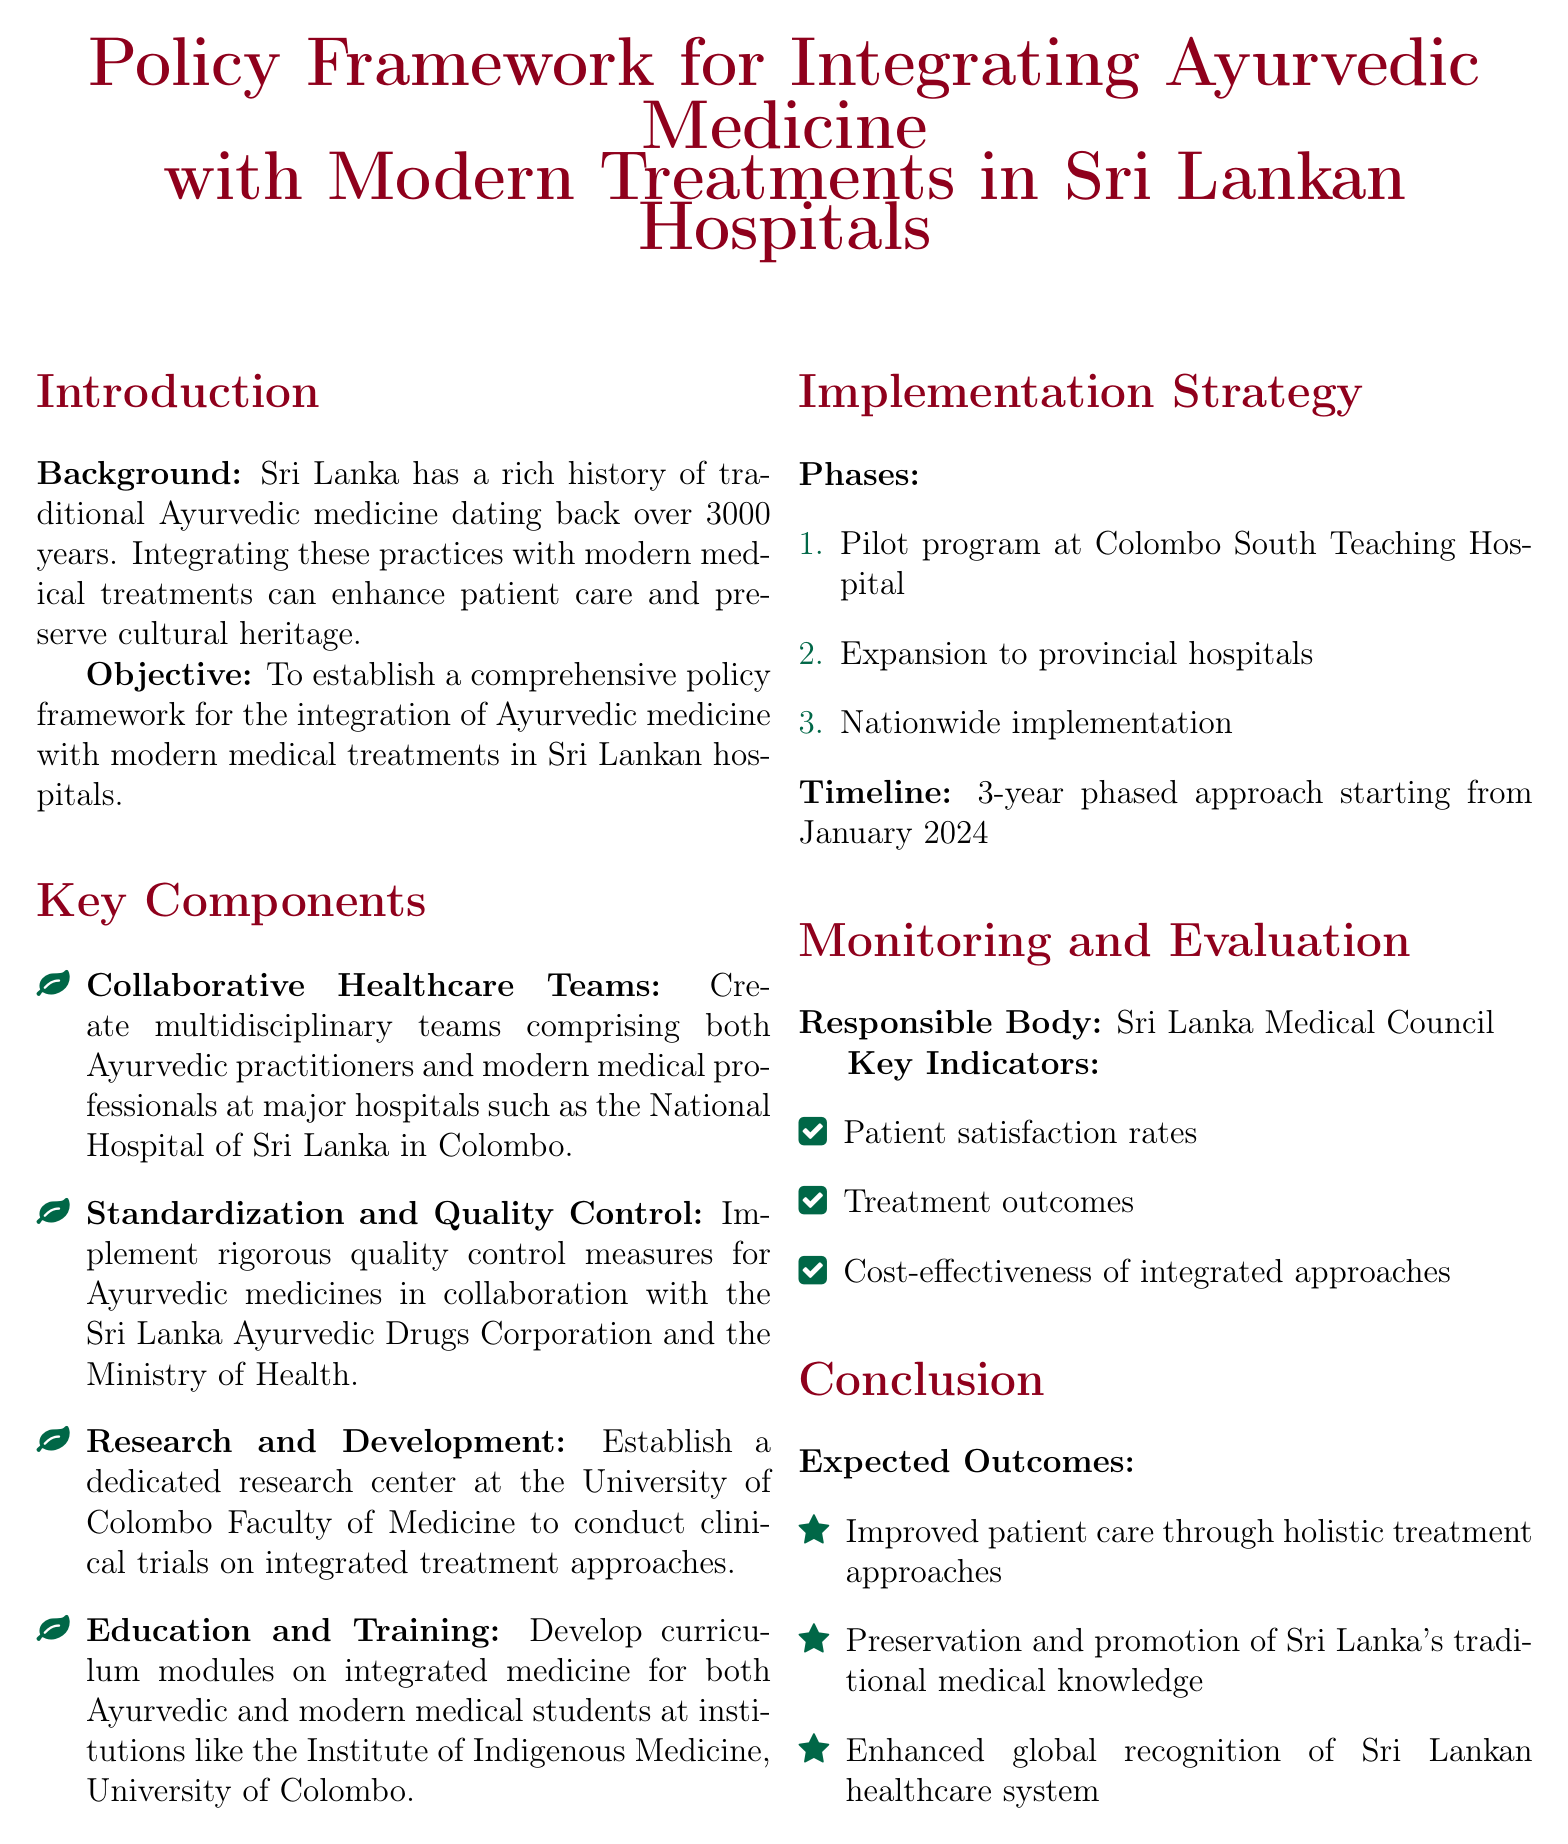What is the primary objective of the policy framework? The document states the objective is to establish a comprehensive policy framework for integration.
Answer: Establish a comprehensive policy framework for the integration of Ayurvedic medicine with modern medical treatments in Sri Lankan hospitals What are the major hospitals mentioned for collaborative healthcare teams? The document specifies which major hospitals will have multidisciplinary teams.
Answer: National Hospital of Sri Lanka in Colombo How many phases are outlined in the implementation strategy? The implementation strategy lists the phases involved for integrating the practices.
Answer: 3 What will the initial pilot program be conducted? The document specifies the location of the pilot program to assess the integration.
Answer: Colombo South Teaching Hospital Who is responsible for monitoring and evaluation? The document indicates the body tasked with the monitoring and evaluation processes.
Answer: Sri Lanka Medical Council What is the expected timeline for the integration program? The document provides a timeframe for the start of the integration project.
Answer: 3-year phased approach starting from January 2024 What key indicator measures patient satisfaction? The document includes a measurement for patient satisfaction rates as a key indicator.
Answer: Patient satisfaction rates Which institute will develop curriculum modules on integrated medicine? The document mentions the educational institution involved in creating curriculum modules.
Answer: Institute of Indigenous Medicine, University of Colombo What is the expected outcome regarding Sri Lanka's traditional medical knowledge? The document outlines the preservation goal as one of the expected outcomes.
Answer: Preservation and promotion of Sri Lanka's traditional medical knowledge 